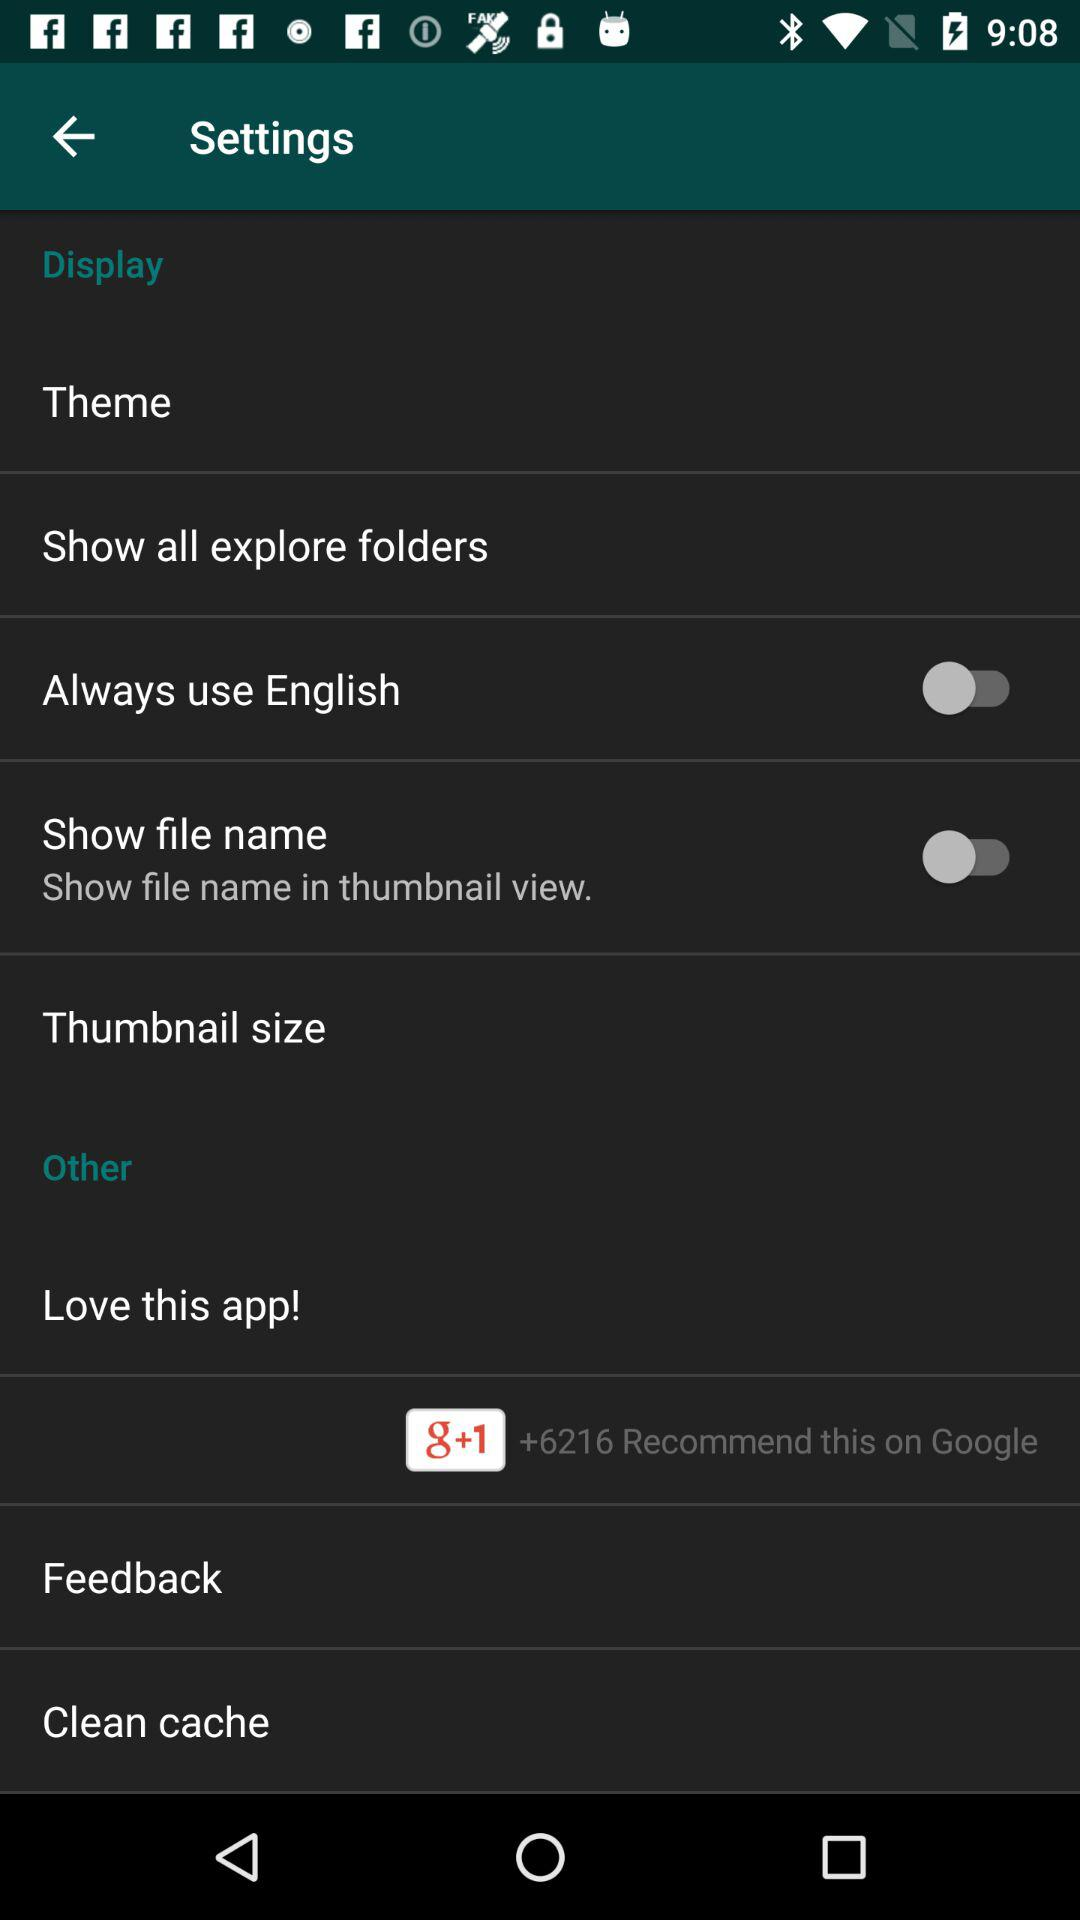How many items in the settings menu have a switch?
Answer the question using a single word or phrase. 2 